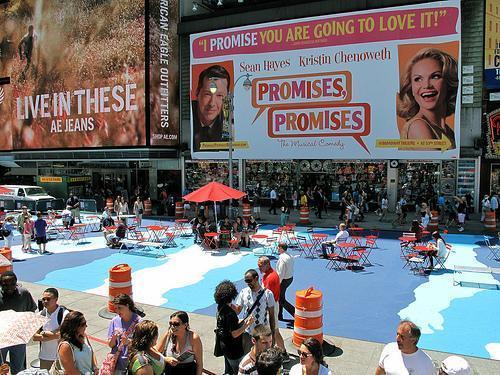How many times is "promises" on the billboard?
Give a very brief answer. 3. 